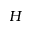<formula> <loc_0><loc_0><loc_500><loc_500>H</formula> 